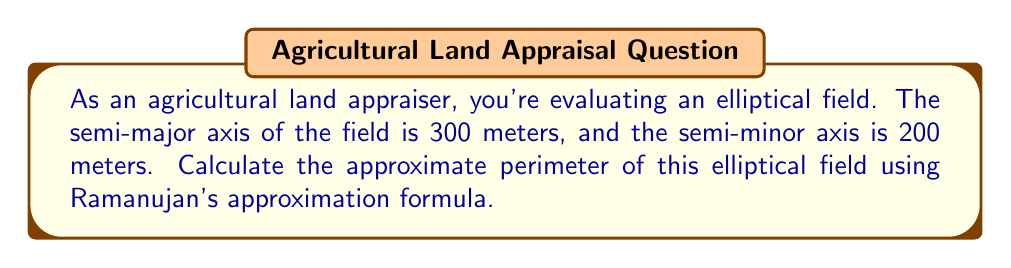Can you solve this math problem? To solve this problem, we'll use Ramanujan's approximation formula for the perimeter of an ellipse. This formula provides a good balance between accuracy and computational simplicity.

Let's define our variables:
$a$ = semi-major axis = 300 meters
$b$ = semi-minor axis = 200 meters

Ramanujan's approximation formula for the perimeter of an ellipse is:

$$P \approx \pi(a+b) \left(1 + \frac{3h}{10 + \sqrt{4-3h}}\right)$$

where $h = \frac{(a-b)^2}{(a+b)^2}$

Step 1: Calculate $h$
$$h = \frac{(300-200)^2}{(300+200)^2} = \frac{10000}{250000} = 0.04$$

Step 2: Substitute the values into Ramanujan's formula
$$P \approx \pi(300+200) \left(1 + \frac{3(0.04)}{10 + \sqrt{4-3(0.04)}}\right)$$

Step 3: Simplify
$$P \approx 500\pi \left(1 + \frac{0.12}{10 + \sqrt{3.88}}\right)$$
$$P \approx 500\pi \left(1 + \frac{0.12}{11.97}\right)$$
$$P \approx 500\pi (1 + 0.01002)$$
$$P \approx 500\pi (1.01002)$$

Step 4: Calculate the final result
$$P \approx 1585.35 \text{ meters}$$

This approximation gives us the perimeter of the elliptical field to two decimal places.
Answer: The approximate perimeter of the elliptical field is 1585.35 meters. 